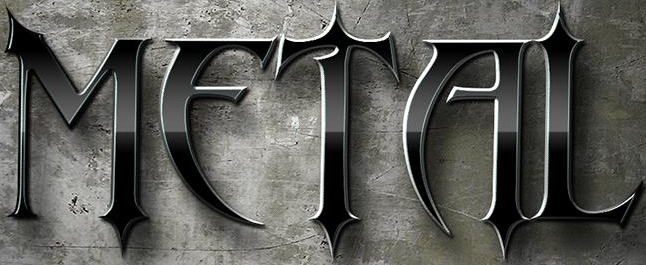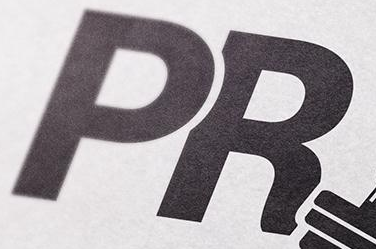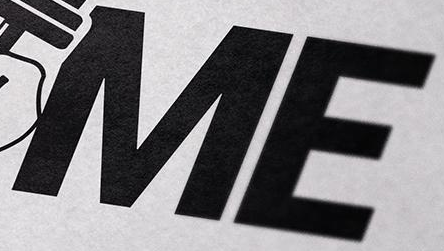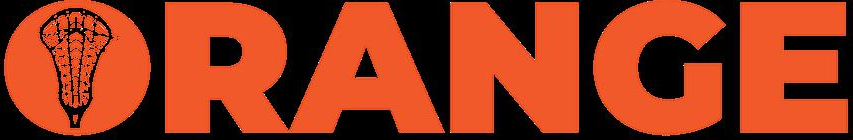What words are shown in these images in order, separated by a semicolon? METAL; PR; ME; ORANGE 